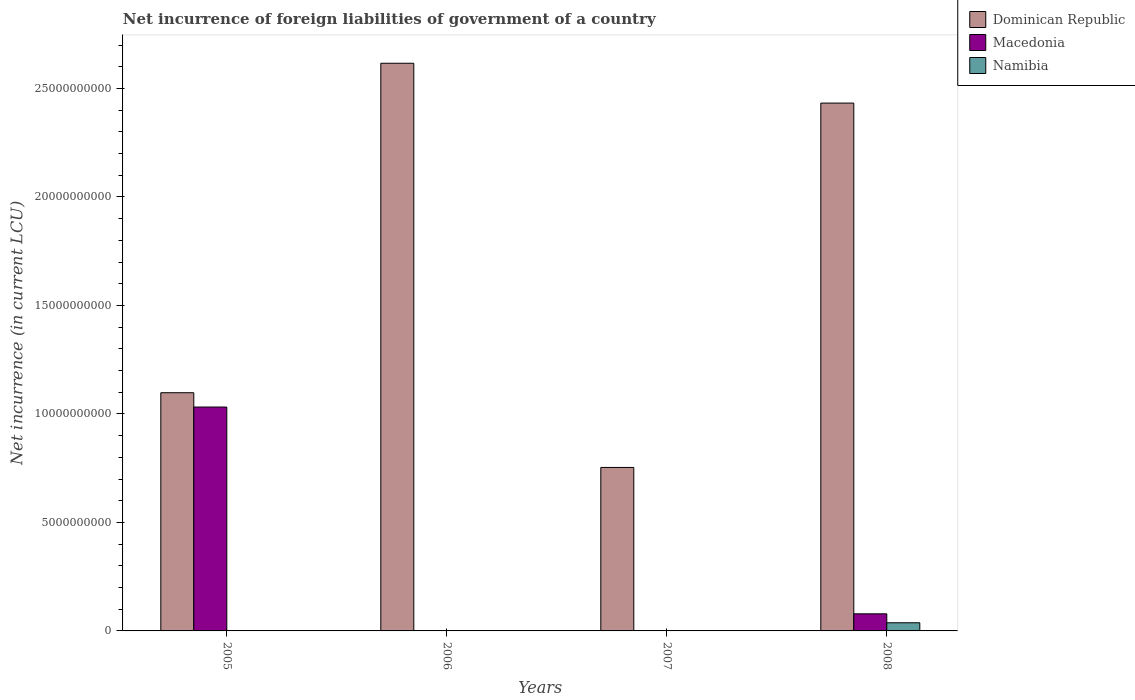How many different coloured bars are there?
Offer a terse response. 3. Are the number of bars per tick equal to the number of legend labels?
Provide a short and direct response. No. How many bars are there on the 2nd tick from the left?
Your answer should be compact. 1. What is the net incurrence of foreign liabilities in Macedonia in 2008?
Offer a terse response. 7.88e+08. Across all years, what is the maximum net incurrence of foreign liabilities in Namibia?
Your answer should be very brief. 3.76e+08. What is the total net incurrence of foreign liabilities in Dominican Republic in the graph?
Provide a short and direct response. 6.90e+1. What is the difference between the net incurrence of foreign liabilities in Dominican Republic in 2007 and that in 2008?
Provide a short and direct response. -1.68e+1. What is the difference between the net incurrence of foreign liabilities in Dominican Republic in 2007 and the net incurrence of foreign liabilities in Macedonia in 2006?
Offer a terse response. 7.53e+09. What is the average net incurrence of foreign liabilities in Macedonia per year?
Offer a very short reply. 2.78e+09. In the year 2005, what is the difference between the net incurrence of foreign liabilities in Macedonia and net incurrence of foreign liabilities in Dominican Republic?
Give a very brief answer. -6.59e+08. In how many years, is the net incurrence of foreign liabilities in Macedonia greater than 9000000000 LCU?
Provide a short and direct response. 1. What is the ratio of the net incurrence of foreign liabilities in Dominican Republic in 2007 to that in 2008?
Your answer should be very brief. 0.31. Is the net incurrence of foreign liabilities in Dominican Republic in 2005 less than that in 2006?
Your answer should be compact. Yes. What is the difference between the highest and the second highest net incurrence of foreign liabilities in Dominican Republic?
Your answer should be very brief. 1.84e+09. What is the difference between the highest and the lowest net incurrence of foreign liabilities in Dominican Republic?
Offer a very short reply. 1.86e+1. In how many years, is the net incurrence of foreign liabilities in Dominican Republic greater than the average net incurrence of foreign liabilities in Dominican Republic taken over all years?
Ensure brevity in your answer.  2. How many bars are there?
Give a very brief answer. 7. Are all the bars in the graph horizontal?
Provide a short and direct response. No. Are the values on the major ticks of Y-axis written in scientific E-notation?
Offer a terse response. No. Does the graph contain any zero values?
Keep it short and to the point. Yes. Does the graph contain grids?
Your response must be concise. No. What is the title of the graph?
Your answer should be very brief. Net incurrence of foreign liabilities of government of a country. What is the label or title of the Y-axis?
Your answer should be very brief. Net incurrence (in current LCU). What is the Net incurrence (in current LCU) in Dominican Republic in 2005?
Offer a very short reply. 1.10e+1. What is the Net incurrence (in current LCU) in Macedonia in 2005?
Offer a very short reply. 1.03e+1. What is the Net incurrence (in current LCU) in Namibia in 2005?
Provide a succinct answer. 0. What is the Net incurrence (in current LCU) of Dominican Republic in 2006?
Offer a terse response. 2.62e+1. What is the Net incurrence (in current LCU) in Macedonia in 2006?
Give a very brief answer. 0. What is the Net incurrence (in current LCU) of Dominican Republic in 2007?
Offer a very short reply. 7.53e+09. What is the Net incurrence (in current LCU) in Dominican Republic in 2008?
Make the answer very short. 2.43e+1. What is the Net incurrence (in current LCU) in Macedonia in 2008?
Give a very brief answer. 7.88e+08. What is the Net incurrence (in current LCU) in Namibia in 2008?
Your answer should be very brief. 3.76e+08. Across all years, what is the maximum Net incurrence (in current LCU) of Dominican Republic?
Your answer should be compact. 2.62e+1. Across all years, what is the maximum Net incurrence (in current LCU) in Macedonia?
Ensure brevity in your answer.  1.03e+1. Across all years, what is the maximum Net incurrence (in current LCU) of Namibia?
Your answer should be very brief. 3.76e+08. Across all years, what is the minimum Net incurrence (in current LCU) in Dominican Republic?
Ensure brevity in your answer.  7.53e+09. Across all years, what is the minimum Net incurrence (in current LCU) of Macedonia?
Your response must be concise. 0. What is the total Net incurrence (in current LCU) in Dominican Republic in the graph?
Your answer should be compact. 6.90e+1. What is the total Net incurrence (in current LCU) of Macedonia in the graph?
Provide a succinct answer. 1.11e+1. What is the total Net incurrence (in current LCU) in Namibia in the graph?
Offer a terse response. 3.76e+08. What is the difference between the Net incurrence (in current LCU) of Dominican Republic in 2005 and that in 2006?
Provide a succinct answer. -1.52e+1. What is the difference between the Net incurrence (in current LCU) of Dominican Republic in 2005 and that in 2007?
Give a very brief answer. 3.44e+09. What is the difference between the Net incurrence (in current LCU) in Dominican Republic in 2005 and that in 2008?
Provide a short and direct response. -1.33e+1. What is the difference between the Net incurrence (in current LCU) in Macedonia in 2005 and that in 2008?
Ensure brevity in your answer.  9.53e+09. What is the difference between the Net incurrence (in current LCU) of Dominican Republic in 2006 and that in 2007?
Your answer should be very brief. 1.86e+1. What is the difference between the Net incurrence (in current LCU) in Dominican Republic in 2006 and that in 2008?
Provide a succinct answer. 1.84e+09. What is the difference between the Net incurrence (in current LCU) of Dominican Republic in 2007 and that in 2008?
Offer a very short reply. -1.68e+1. What is the difference between the Net incurrence (in current LCU) of Dominican Republic in 2005 and the Net incurrence (in current LCU) of Macedonia in 2008?
Make the answer very short. 1.02e+1. What is the difference between the Net incurrence (in current LCU) in Dominican Republic in 2005 and the Net incurrence (in current LCU) in Namibia in 2008?
Your answer should be compact. 1.06e+1. What is the difference between the Net incurrence (in current LCU) of Macedonia in 2005 and the Net incurrence (in current LCU) of Namibia in 2008?
Provide a succinct answer. 9.94e+09. What is the difference between the Net incurrence (in current LCU) in Dominican Republic in 2006 and the Net incurrence (in current LCU) in Macedonia in 2008?
Your answer should be compact. 2.54e+1. What is the difference between the Net incurrence (in current LCU) of Dominican Republic in 2006 and the Net incurrence (in current LCU) of Namibia in 2008?
Offer a terse response. 2.58e+1. What is the difference between the Net incurrence (in current LCU) in Dominican Republic in 2007 and the Net incurrence (in current LCU) in Macedonia in 2008?
Offer a very short reply. 6.75e+09. What is the difference between the Net incurrence (in current LCU) in Dominican Republic in 2007 and the Net incurrence (in current LCU) in Namibia in 2008?
Your answer should be compact. 7.16e+09. What is the average Net incurrence (in current LCU) in Dominican Republic per year?
Provide a succinct answer. 1.72e+1. What is the average Net incurrence (in current LCU) of Macedonia per year?
Your answer should be compact. 2.78e+09. What is the average Net incurrence (in current LCU) in Namibia per year?
Give a very brief answer. 9.39e+07. In the year 2005, what is the difference between the Net incurrence (in current LCU) of Dominican Republic and Net incurrence (in current LCU) of Macedonia?
Ensure brevity in your answer.  6.59e+08. In the year 2008, what is the difference between the Net incurrence (in current LCU) in Dominican Republic and Net incurrence (in current LCU) in Macedonia?
Ensure brevity in your answer.  2.35e+1. In the year 2008, what is the difference between the Net incurrence (in current LCU) in Dominican Republic and Net incurrence (in current LCU) in Namibia?
Provide a short and direct response. 2.39e+1. In the year 2008, what is the difference between the Net incurrence (in current LCU) in Macedonia and Net incurrence (in current LCU) in Namibia?
Keep it short and to the point. 4.12e+08. What is the ratio of the Net incurrence (in current LCU) of Dominican Republic in 2005 to that in 2006?
Your answer should be compact. 0.42. What is the ratio of the Net incurrence (in current LCU) of Dominican Republic in 2005 to that in 2007?
Your response must be concise. 1.46. What is the ratio of the Net incurrence (in current LCU) of Dominican Republic in 2005 to that in 2008?
Your answer should be compact. 0.45. What is the ratio of the Net incurrence (in current LCU) in Macedonia in 2005 to that in 2008?
Your answer should be very brief. 13.09. What is the ratio of the Net incurrence (in current LCU) in Dominican Republic in 2006 to that in 2007?
Offer a terse response. 3.47. What is the ratio of the Net incurrence (in current LCU) of Dominican Republic in 2006 to that in 2008?
Ensure brevity in your answer.  1.08. What is the ratio of the Net incurrence (in current LCU) in Dominican Republic in 2007 to that in 2008?
Your response must be concise. 0.31. What is the difference between the highest and the second highest Net incurrence (in current LCU) in Dominican Republic?
Keep it short and to the point. 1.84e+09. What is the difference between the highest and the lowest Net incurrence (in current LCU) of Dominican Republic?
Your response must be concise. 1.86e+1. What is the difference between the highest and the lowest Net incurrence (in current LCU) of Macedonia?
Your answer should be compact. 1.03e+1. What is the difference between the highest and the lowest Net incurrence (in current LCU) in Namibia?
Give a very brief answer. 3.76e+08. 